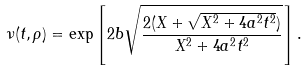<formula> <loc_0><loc_0><loc_500><loc_500>\nu ( t , \rho ) = \exp \left [ 2 b \sqrt { \frac { 2 ( X + \sqrt { X ^ { 2 } + 4 a ^ { 2 } t ^ { 2 } } ) } { X ^ { 2 } + 4 a ^ { 2 } t ^ { 2 } } } \right ] .</formula> 